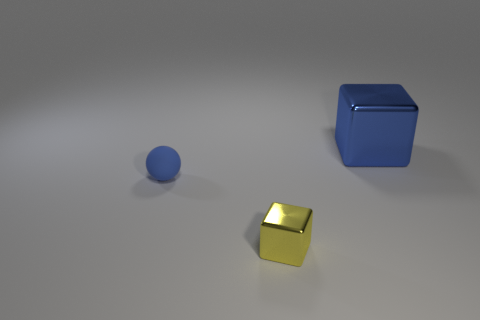Do the small rubber object and the big thing have the same color?
Keep it short and to the point. Yes. There is a object that is in front of the tiny thing that is to the left of the yellow object; what is it made of?
Provide a short and direct response. Metal. Is the shape of the shiny object in front of the tiny ball the same as the blue object on the left side of the blue metal object?
Ensure brevity in your answer.  No. There is a thing that is both in front of the big blue shiny thing and behind the small yellow shiny block; what is its size?
Provide a succinct answer. Small. What number of other things are the same color as the big cube?
Offer a terse response. 1. Is the material of the block that is behind the rubber thing the same as the small yellow thing?
Offer a terse response. Yes. Is there anything else that is the same size as the blue block?
Provide a succinct answer. No. Is the number of yellow blocks to the left of the rubber object less than the number of blue rubber spheres that are right of the yellow object?
Your response must be concise. No. Is there anything else that has the same shape as the big metallic thing?
Your answer should be very brief. Yes. There is a large thing that is the same color as the tiny rubber sphere; what material is it?
Ensure brevity in your answer.  Metal. 